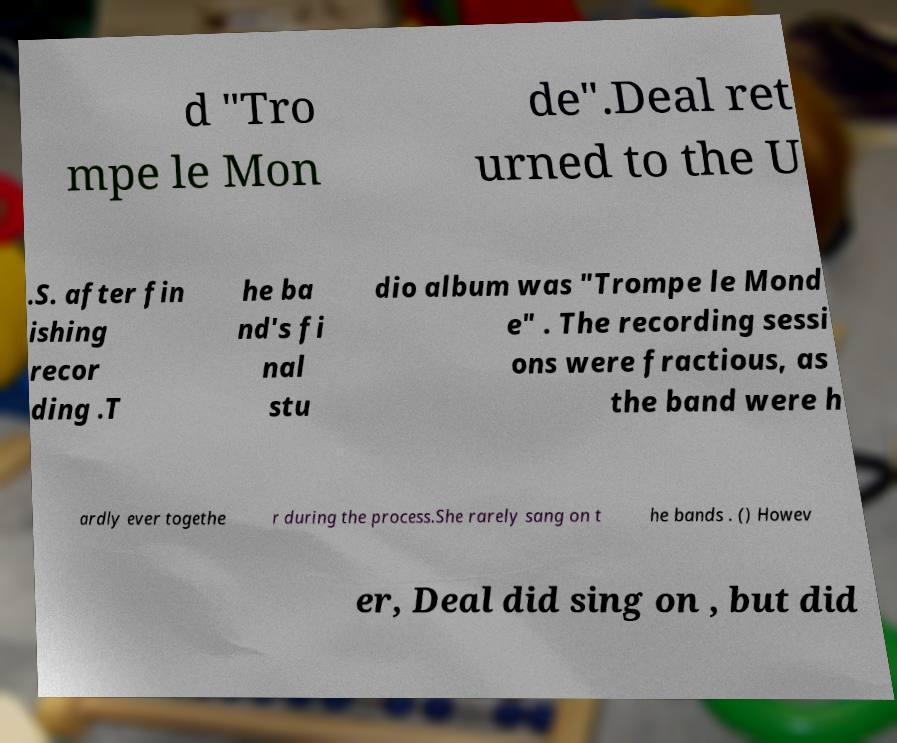Can you accurately transcribe the text from the provided image for me? d "Tro mpe le Mon de".Deal ret urned to the U .S. after fin ishing recor ding .T he ba nd's fi nal stu dio album was "Trompe le Mond e" . The recording sessi ons were fractious, as the band were h ardly ever togethe r during the process.She rarely sang on t he bands . () Howev er, Deal did sing on , but did 